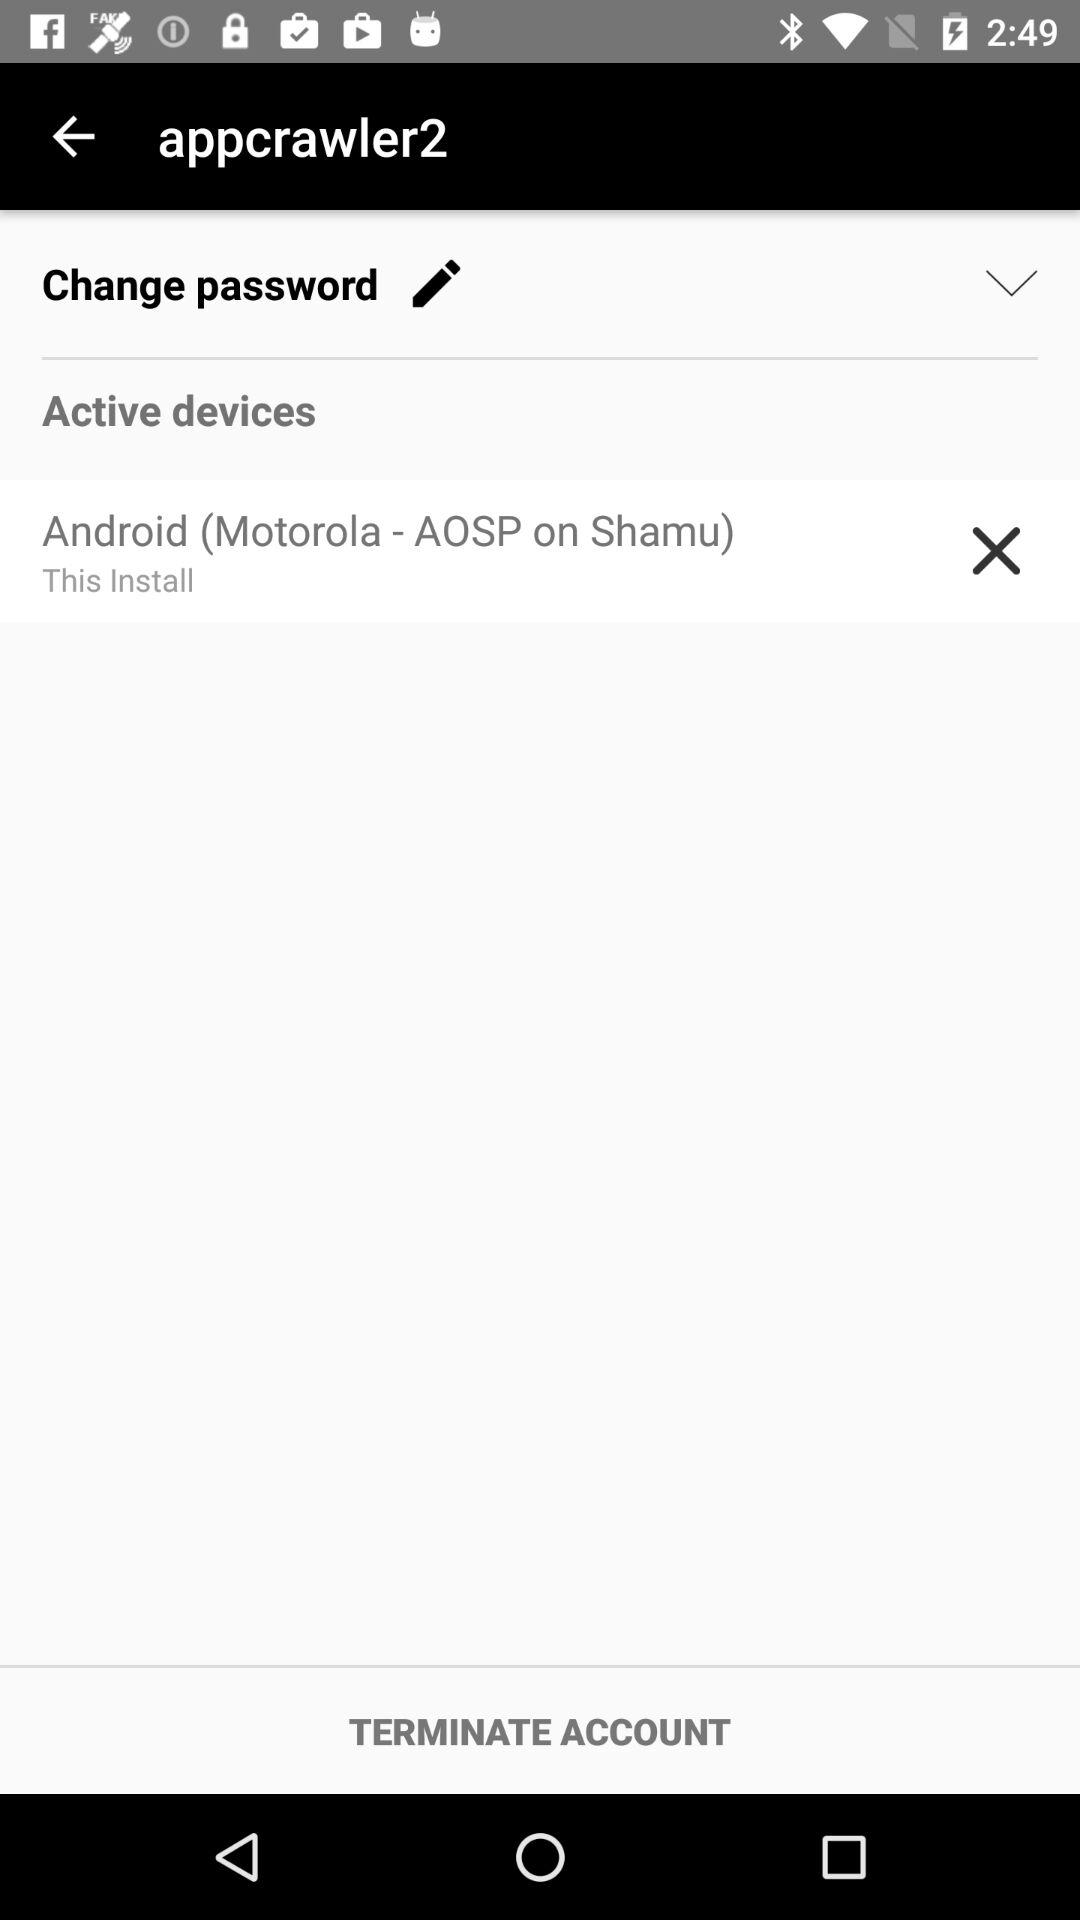What is the username? The username is "appcrawler2". 